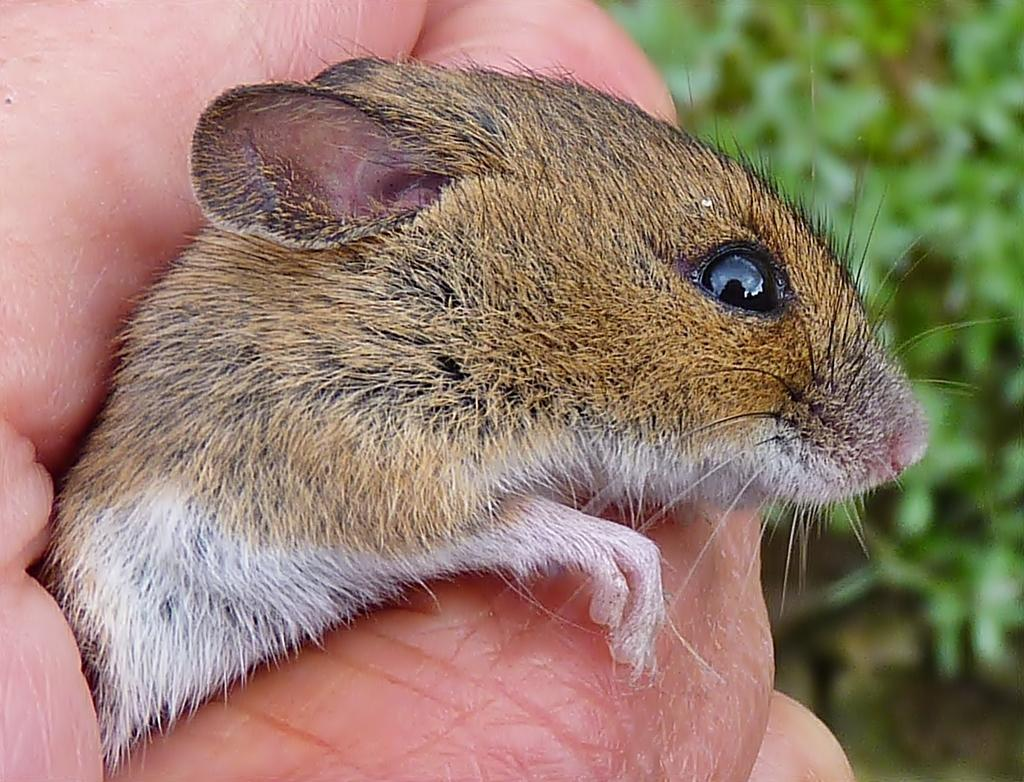What is the focus of the image? The image is zoomed in on a hand of a person. What is the hand holding? The hand is holding an animal. What can be seen in the background of the image? There are green color objects in the background, which seem to be plants. What type of road can be seen in the image? There is no road present in the image; it features a hand holding an animal with a background of plants. 